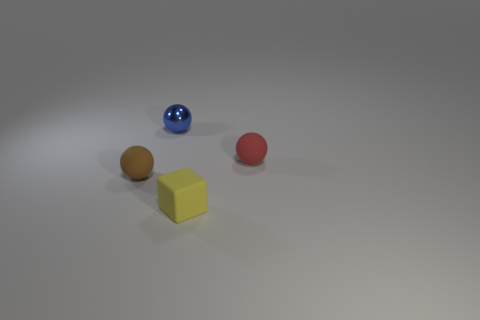Subtract all brown balls. How many balls are left? 2 Subtract all blue spheres. How many spheres are left? 2 Subtract 2 balls. How many balls are left? 1 Add 3 tiny purple blocks. How many objects exist? 7 Subtract all purple cubes. How many brown balls are left? 1 Subtract all cubes. How many objects are left? 3 Subtract all cyan blocks. Subtract all cyan balls. How many blocks are left? 1 Subtract all metal objects. Subtract all spheres. How many objects are left? 0 Add 4 rubber blocks. How many rubber blocks are left? 5 Add 2 small red matte spheres. How many small red matte spheres exist? 3 